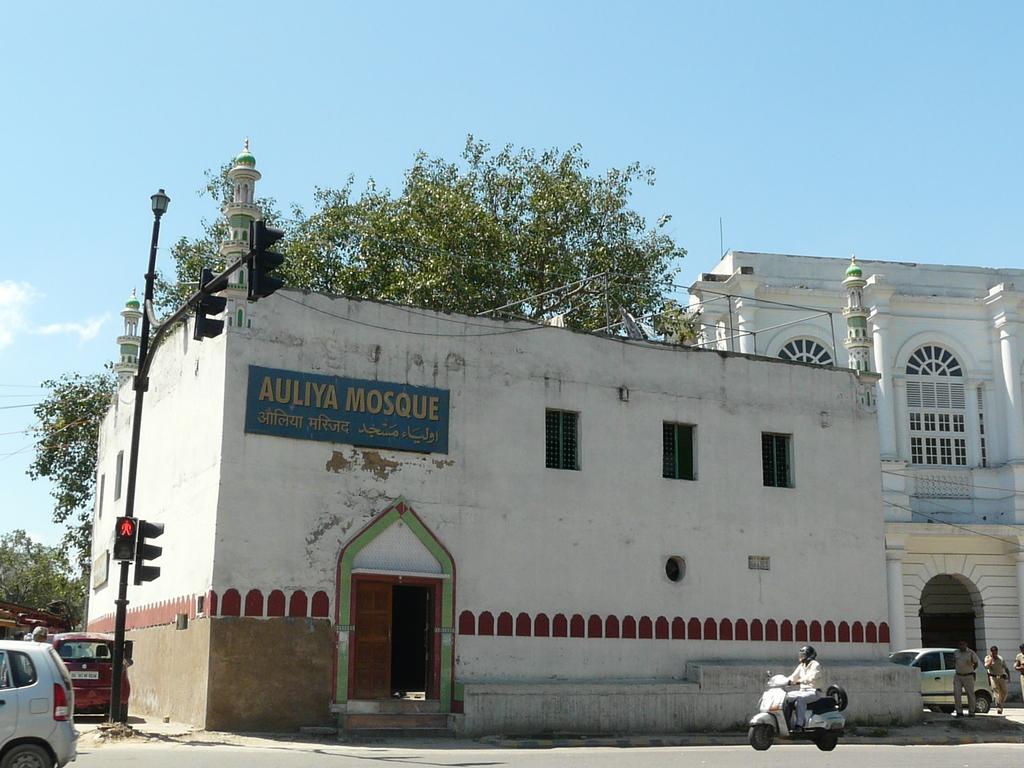Please provide a concise description of this image. This picture is clicked outside the city. The man in a white shirt who is wearing a helmet is riding the scooter. Beside him, we see a mosque. On the left side, we see vehicles parked on the road. We even see traffic signals and street lights. On the right side, we see a car parked on the road and the police officers are walking on the road. Behind them, we see a building in white color. There are trees in the background. At the top of the picture, we see the sky. 